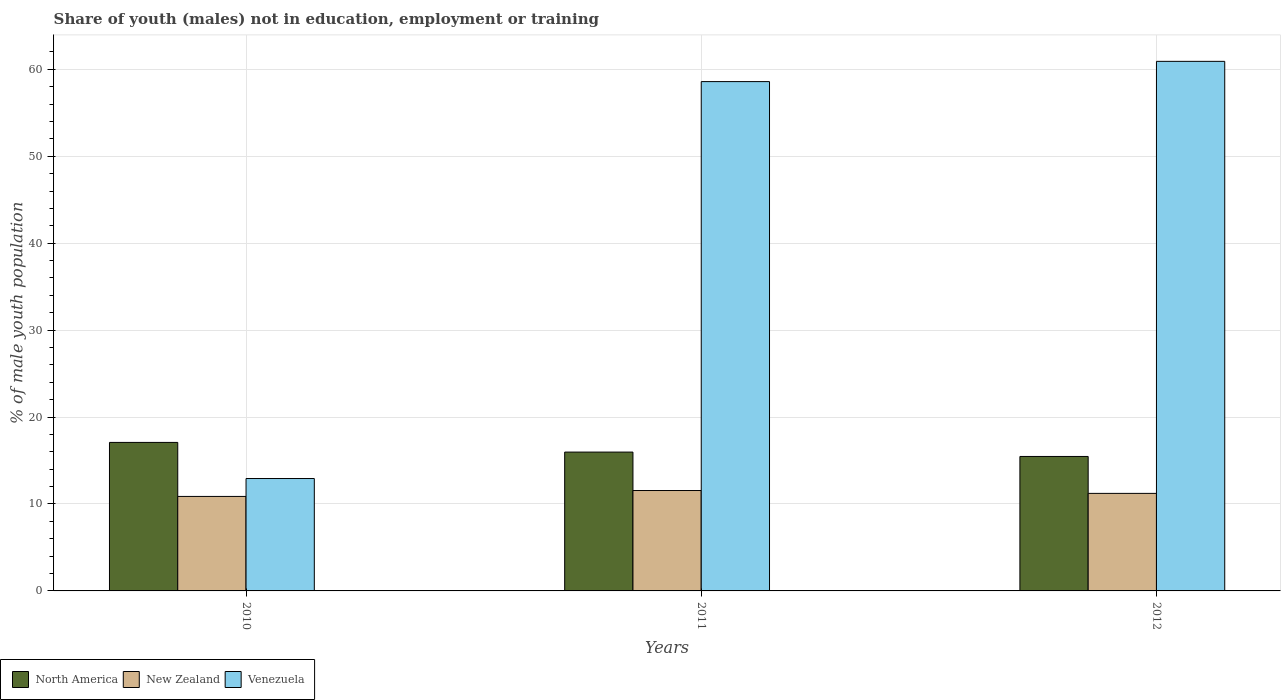How many groups of bars are there?
Ensure brevity in your answer.  3. How many bars are there on the 3rd tick from the left?
Give a very brief answer. 3. What is the label of the 1st group of bars from the left?
Your answer should be very brief. 2010. What is the percentage of unemployed males population in in Venezuela in 2012?
Offer a very short reply. 60.92. Across all years, what is the maximum percentage of unemployed males population in in New Zealand?
Ensure brevity in your answer.  11.55. Across all years, what is the minimum percentage of unemployed males population in in Venezuela?
Provide a short and direct response. 12.93. What is the total percentage of unemployed males population in in New Zealand in the graph?
Provide a succinct answer. 33.64. What is the difference between the percentage of unemployed males population in in New Zealand in 2011 and that in 2012?
Your answer should be compact. 0.33. What is the difference between the percentage of unemployed males population in in New Zealand in 2010 and the percentage of unemployed males population in in Venezuela in 2012?
Offer a very short reply. -50.05. What is the average percentage of unemployed males population in in North America per year?
Provide a succinct answer. 16.17. In the year 2011, what is the difference between the percentage of unemployed males population in in Venezuela and percentage of unemployed males population in in New Zealand?
Offer a terse response. 47.04. In how many years, is the percentage of unemployed males population in in New Zealand greater than 44 %?
Provide a succinct answer. 0. What is the ratio of the percentage of unemployed males population in in North America in 2010 to that in 2012?
Your response must be concise. 1.1. What is the difference between the highest and the second highest percentage of unemployed males population in in North America?
Offer a terse response. 1.11. What is the difference between the highest and the lowest percentage of unemployed males population in in New Zealand?
Make the answer very short. 0.68. In how many years, is the percentage of unemployed males population in in Venezuela greater than the average percentage of unemployed males population in in Venezuela taken over all years?
Your answer should be very brief. 2. Is the sum of the percentage of unemployed males population in in North America in 2010 and 2012 greater than the maximum percentage of unemployed males population in in Venezuela across all years?
Give a very brief answer. No. What does the 1st bar from the left in 2012 represents?
Make the answer very short. North America. Is it the case that in every year, the sum of the percentage of unemployed males population in in New Zealand and percentage of unemployed males population in in North America is greater than the percentage of unemployed males population in in Venezuela?
Provide a succinct answer. No. How many bars are there?
Give a very brief answer. 9. Are the values on the major ticks of Y-axis written in scientific E-notation?
Offer a terse response. No. Where does the legend appear in the graph?
Offer a terse response. Bottom left. How many legend labels are there?
Provide a succinct answer. 3. How are the legend labels stacked?
Your answer should be very brief. Horizontal. What is the title of the graph?
Make the answer very short. Share of youth (males) not in education, employment or training. Does "Small states" appear as one of the legend labels in the graph?
Provide a succinct answer. No. What is the label or title of the X-axis?
Your answer should be very brief. Years. What is the label or title of the Y-axis?
Provide a succinct answer. % of male youth population. What is the % of male youth population of North America in 2010?
Ensure brevity in your answer.  17.08. What is the % of male youth population of New Zealand in 2010?
Your answer should be very brief. 10.87. What is the % of male youth population in Venezuela in 2010?
Offer a very short reply. 12.93. What is the % of male youth population in North America in 2011?
Give a very brief answer. 15.97. What is the % of male youth population in New Zealand in 2011?
Provide a succinct answer. 11.55. What is the % of male youth population in Venezuela in 2011?
Your response must be concise. 58.59. What is the % of male youth population in North America in 2012?
Offer a very short reply. 15.47. What is the % of male youth population in New Zealand in 2012?
Ensure brevity in your answer.  11.22. What is the % of male youth population of Venezuela in 2012?
Give a very brief answer. 60.92. Across all years, what is the maximum % of male youth population in North America?
Your answer should be compact. 17.08. Across all years, what is the maximum % of male youth population in New Zealand?
Provide a succinct answer. 11.55. Across all years, what is the maximum % of male youth population in Venezuela?
Keep it short and to the point. 60.92. Across all years, what is the minimum % of male youth population of North America?
Keep it short and to the point. 15.47. Across all years, what is the minimum % of male youth population of New Zealand?
Offer a very short reply. 10.87. Across all years, what is the minimum % of male youth population in Venezuela?
Offer a very short reply. 12.93. What is the total % of male youth population in North America in the graph?
Make the answer very short. 48.52. What is the total % of male youth population of New Zealand in the graph?
Provide a succinct answer. 33.64. What is the total % of male youth population in Venezuela in the graph?
Give a very brief answer. 132.44. What is the difference between the % of male youth population of North America in 2010 and that in 2011?
Make the answer very short. 1.11. What is the difference between the % of male youth population of New Zealand in 2010 and that in 2011?
Provide a succinct answer. -0.68. What is the difference between the % of male youth population of Venezuela in 2010 and that in 2011?
Your answer should be very brief. -45.66. What is the difference between the % of male youth population of North America in 2010 and that in 2012?
Your response must be concise. 1.62. What is the difference between the % of male youth population in New Zealand in 2010 and that in 2012?
Provide a succinct answer. -0.35. What is the difference between the % of male youth population in Venezuela in 2010 and that in 2012?
Your response must be concise. -47.99. What is the difference between the % of male youth population of North America in 2011 and that in 2012?
Ensure brevity in your answer.  0.5. What is the difference between the % of male youth population in New Zealand in 2011 and that in 2012?
Make the answer very short. 0.33. What is the difference between the % of male youth population of Venezuela in 2011 and that in 2012?
Your answer should be very brief. -2.33. What is the difference between the % of male youth population in North America in 2010 and the % of male youth population in New Zealand in 2011?
Give a very brief answer. 5.53. What is the difference between the % of male youth population of North America in 2010 and the % of male youth population of Venezuela in 2011?
Keep it short and to the point. -41.51. What is the difference between the % of male youth population in New Zealand in 2010 and the % of male youth population in Venezuela in 2011?
Your response must be concise. -47.72. What is the difference between the % of male youth population in North America in 2010 and the % of male youth population in New Zealand in 2012?
Give a very brief answer. 5.86. What is the difference between the % of male youth population in North America in 2010 and the % of male youth population in Venezuela in 2012?
Provide a short and direct response. -43.84. What is the difference between the % of male youth population of New Zealand in 2010 and the % of male youth population of Venezuela in 2012?
Provide a succinct answer. -50.05. What is the difference between the % of male youth population in North America in 2011 and the % of male youth population in New Zealand in 2012?
Your answer should be compact. 4.75. What is the difference between the % of male youth population of North America in 2011 and the % of male youth population of Venezuela in 2012?
Your response must be concise. -44.95. What is the difference between the % of male youth population in New Zealand in 2011 and the % of male youth population in Venezuela in 2012?
Ensure brevity in your answer.  -49.37. What is the average % of male youth population of North America per year?
Your answer should be compact. 16.17. What is the average % of male youth population in New Zealand per year?
Give a very brief answer. 11.21. What is the average % of male youth population in Venezuela per year?
Your answer should be compact. 44.15. In the year 2010, what is the difference between the % of male youth population of North America and % of male youth population of New Zealand?
Give a very brief answer. 6.21. In the year 2010, what is the difference between the % of male youth population of North America and % of male youth population of Venezuela?
Offer a very short reply. 4.15. In the year 2010, what is the difference between the % of male youth population of New Zealand and % of male youth population of Venezuela?
Your answer should be very brief. -2.06. In the year 2011, what is the difference between the % of male youth population of North America and % of male youth population of New Zealand?
Your response must be concise. 4.42. In the year 2011, what is the difference between the % of male youth population of North America and % of male youth population of Venezuela?
Make the answer very short. -42.62. In the year 2011, what is the difference between the % of male youth population of New Zealand and % of male youth population of Venezuela?
Offer a very short reply. -47.04. In the year 2012, what is the difference between the % of male youth population in North America and % of male youth population in New Zealand?
Make the answer very short. 4.25. In the year 2012, what is the difference between the % of male youth population of North America and % of male youth population of Venezuela?
Provide a short and direct response. -45.45. In the year 2012, what is the difference between the % of male youth population of New Zealand and % of male youth population of Venezuela?
Ensure brevity in your answer.  -49.7. What is the ratio of the % of male youth population in North America in 2010 to that in 2011?
Provide a succinct answer. 1.07. What is the ratio of the % of male youth population in New Zealand in 2010 to that in 2011?
Your response must be concise. 0.94. What is the ratio of the % of male youth population in Venezuela in 2010 to that in 2011?
Provide a short and direct response. 0.22. What is the ratio of the % of male youth population of North America in 2010 to that in 2012?
Provide a short and direct response. 1.1. What is the ratio of the % of male youth population of New Zealand in 2010 to that in 2012?
Give a very brief answer. 0.97. What is the ratio of the % of male youth population of Venezuela in 2010 to that in 2012?
Make the answer very short. 0.21. What is the ratio of the % of male youth population in North America in 2011 to that in 2012?
Your response must be concise. 1.03. What is the ratio of the % of male youth population in New Zealand in 2011 to that in 2012?
Provide a succinct answer. 1.03. What is the ratio of the % of male youth population in Venezuela in 2011 to that in 2012?
Offer a very short reply. 0.96. What is the difference between the highest and the second highest % of male youth population in North America?
Your answer should be compact. 1.11. What is the difference between the highest and the second highest % of male youth population in New Zealand?
Give a very brief answer. 0.33. What is the difference between the highest and the second highest % of male youth population in Venezuela?
Your answer should be very brief. 2.33. What is the difference between the highest and the lowest % of male youth population of North America?
Provide a short and direct response. 1.62. What is the difference between the highest and the lowest % of male youth population of New Zealand?
Ensure brevity in your answer.  0.68. What is the difference between the highest and the lowest % of male youth population of Venezuela?
Offer a terse response. 47.99. 